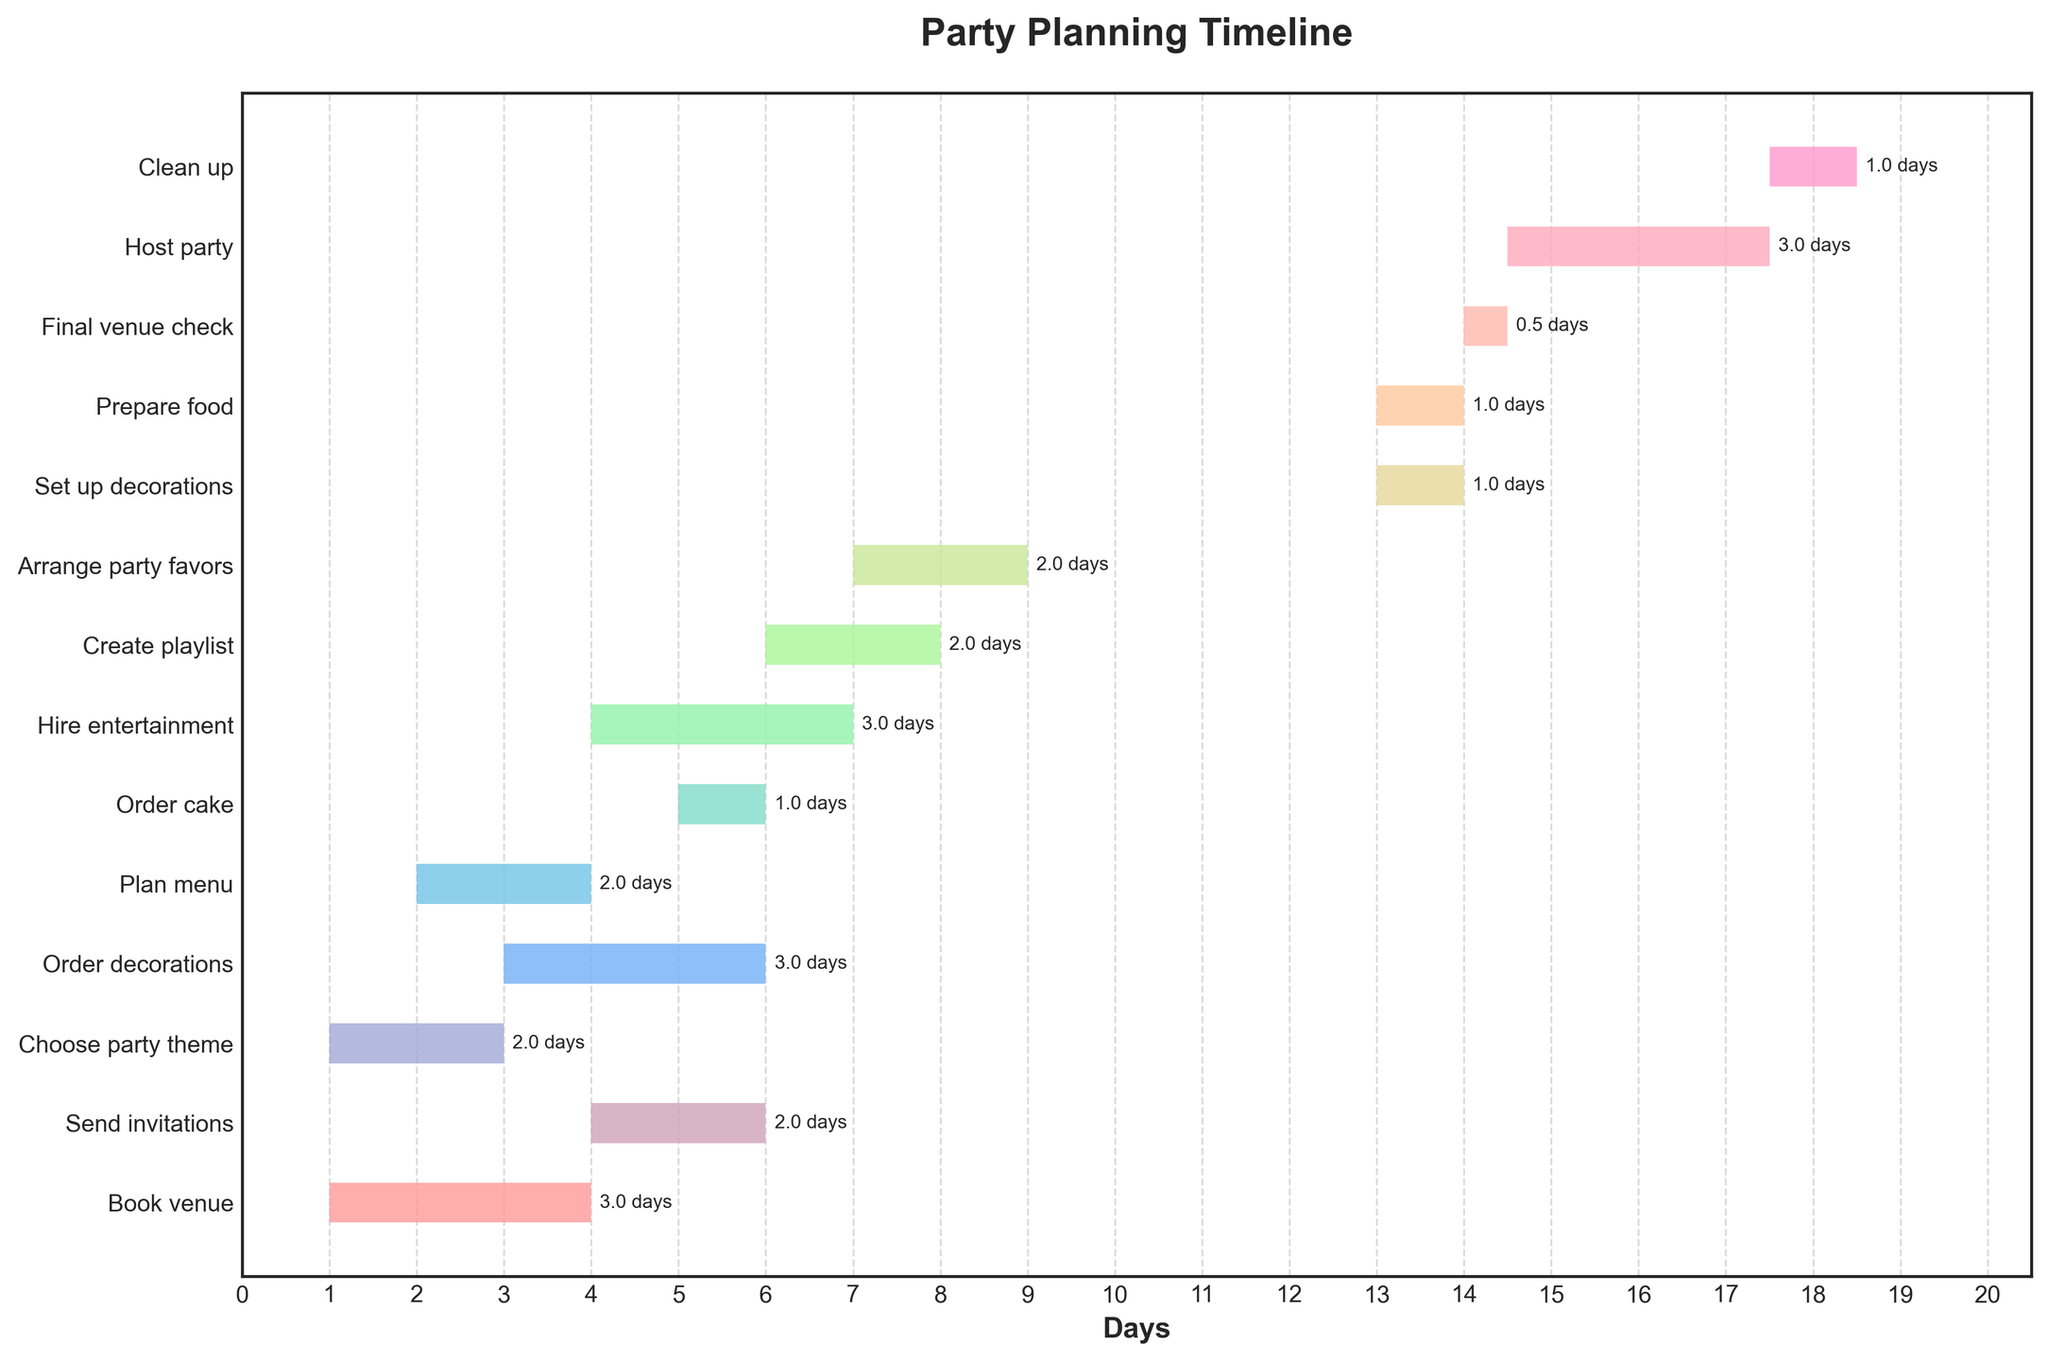Which task starts first? The Gantt Chart shows the tasks' start times on a horizontal axis. The first tasks placed on the left side of the timeline are "Book venue" and "Choose party theme," which both start on day 1.
Answer: Book venue, Choose party theme How long does it take to prepare the food? On the Gantt Chart, the "Prepare food" task starts on day 13 and has a duration of 1 day. This information is found where the "Prepare food" bar is placed.
Answer: 1 day What is the last task on the timeline? The last task, based on the position of the bars from left to right on the Gantt Chart, is "Clean up," which starts on day 17.5 and has a duration of 1 day.
Answer: Clean up What is the total time allocated to set up decorations and prepare food? The Gantt Chart shows "Set up decorations" and "Prepare food" both starting on day 13. Both tasks have a duration of 1 day each. Summing the durations (1 + 1) gives the total time.
Answer: 2 days Which task has the longest duration? By comparing the length of all bars visually in the Gantt Chart, the "Hire entertainment" task has the longest duration of 3 days.
Answer: Hire entertainment Do any tasks overlap on the timeline? Tasks overlap if their bars visually intersect on the timeline. "Send invitations" and "Order decorations" overlap as they start on day 4 and day 3, respectively, and their durations intersect.
Answer: Yes Which task begins immediately after "Plan menu"? According to the Gantt Chart timeline, "Send invitations" starts on day 4, right after "Plan menu" which ends on day 4.
Answer: Send invitations What is the duration of the party? The "Host party" task starts at day 14.5 and has a duration of 3 days, as shown by its bar on the Gantt Chart.
Answer: 3 days How many tasks start on day 4? The tasks "Send invitations" and "Hire entertainment" both have start times labeled as day 4 on the timeline. Counting these bars gives a total of 2 tasks.
Answer: 2 tasks Which tasks need to be completed before "Order cake"? Tasks need to be completed if their end times are on or before the start time of "Order cake," which starts on day 5. The tasks "Book venue," "Choose party theme," "Plan menu," and "Order decorations" all end on or before day 5.
Answer: Book venue, Choose party theme, Plan menu, Order decorations 